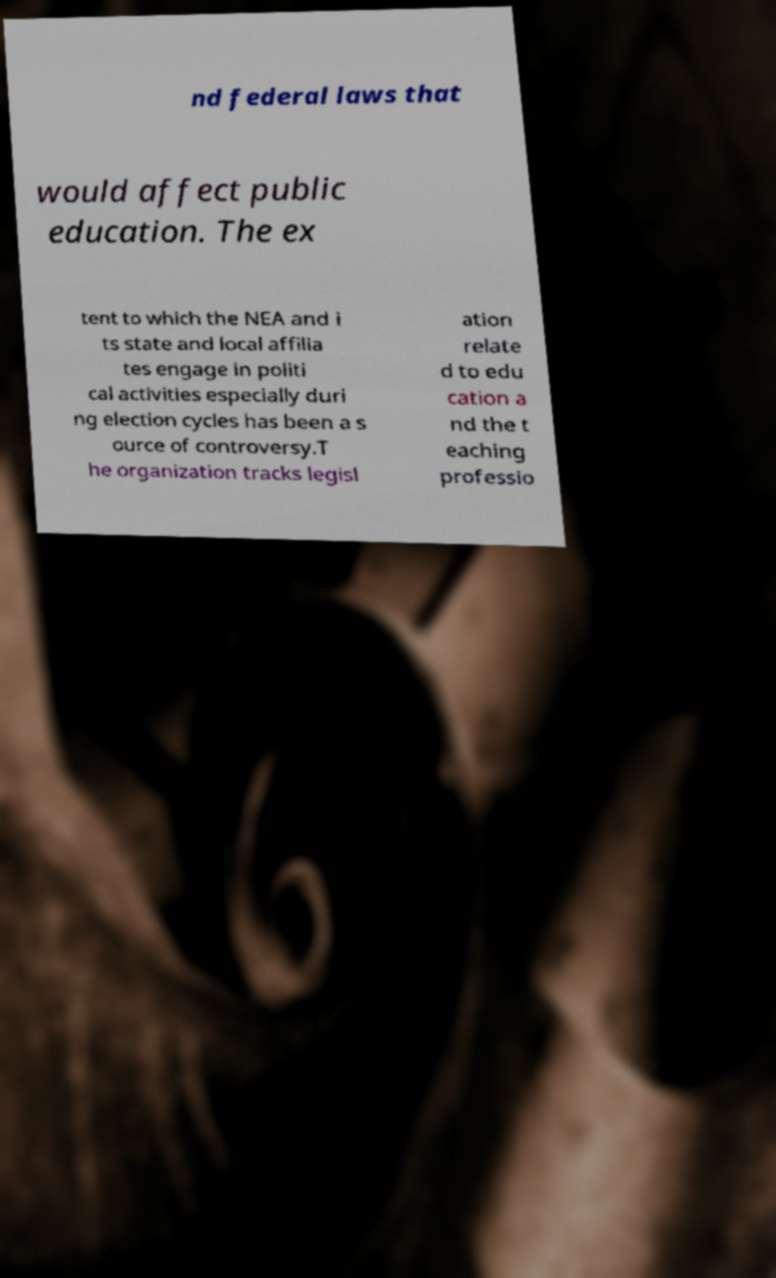Can you read and provide the text displayed in the image?This photo seems to have some interesting text. Can you extract and type it out for me? nd federal laws that would affect public education. The ex tent to which the NEA and i ts state and local affilia tes engage in politi cal activities especially duri ng election cycles has been a s ource of controversy.T he organization tracks legisl ation relate d to edu cation a nd the t eaching professio 